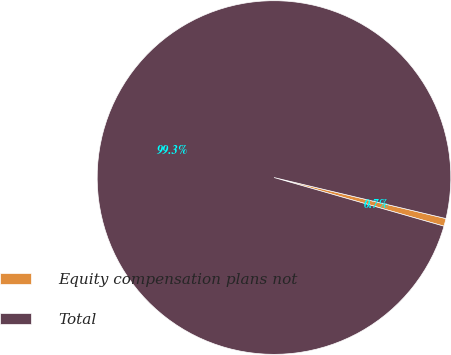Convert chart. <chart><loc_0><loc_0><loc_500><loc_500><pie_chart><fcel>Equity compensation plans not<fcel>Total<nl><fcel>0.71%<fcel>99.29%<nl></chart> 